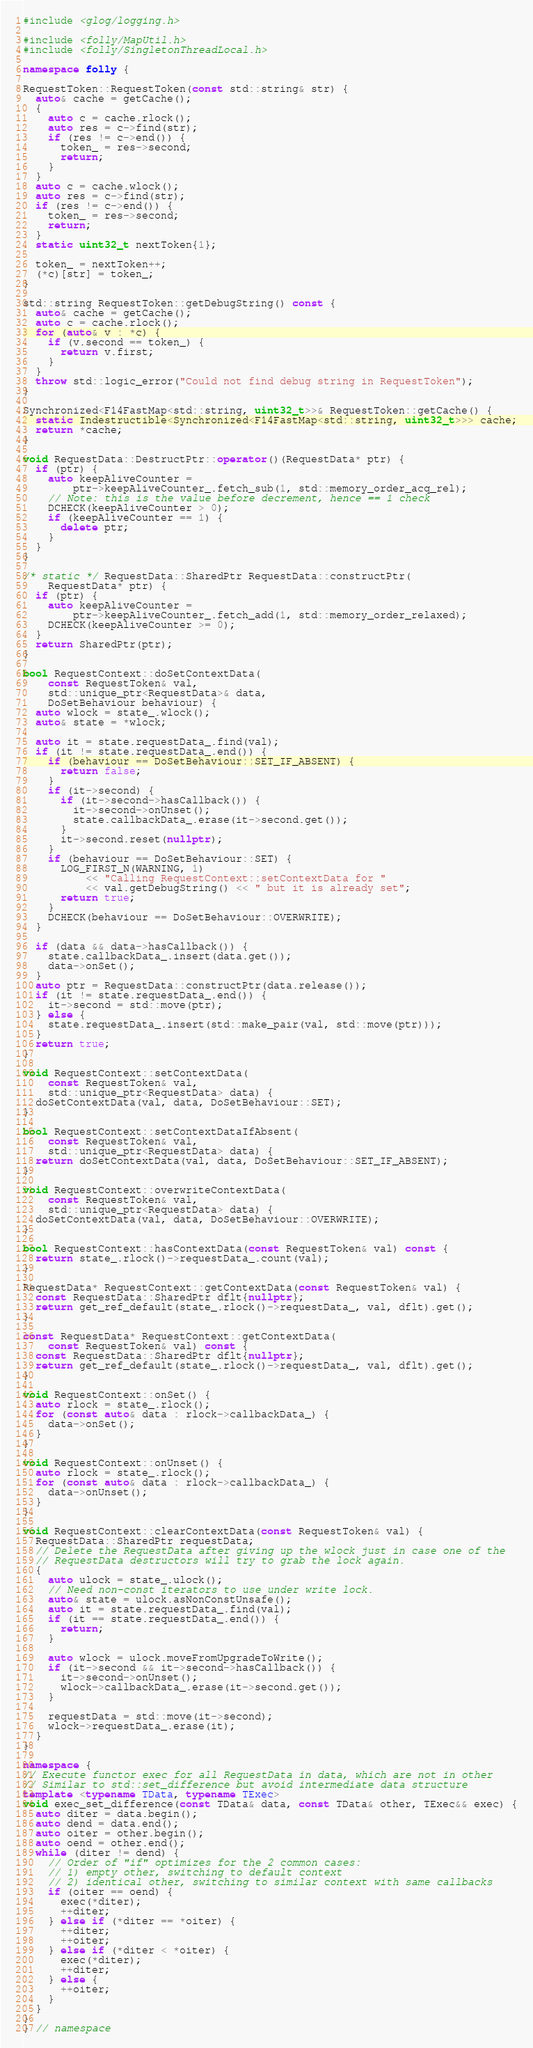<code> <loc_0><loc_0><loc_500><loc_500><_C++_>
#include <glog/logging.h>

#include <folly/MapUtil.h>
#include <folly/SingletonThreadLocal.h>

namespace folly {

RequestToken::RequestToken(const std::string& str) {
  auto& cache = getCache();
  {
    auto c = cache.rlock();
    auto res = c->find(str);
    if (res != c->end()) {
      token_ = res->second;
      return;
    }
  }
  auto c = cache.wlock();
  auto res = c->find(str);
  if (res != c->end()) {
    token_ = res->second;
    return;
  }
  static uint32_t nextToken{1};

  token_ = nextToken++;
  (*c)[str] = token_;
}

std::string RequestToken::getDebugString() const {
  auto& cache = getCache();
  auto c = cache.rlock();
  for (auto& v : *c) {
    if (v.second == token_) {
      return v.first;
    }
  }
  throw std::logic_error("Could not find debug string in RequestToken");
}

Synchronized<F14FastMap<std::string, uint32_t>>& RequestToken::getCache() {
  static Indestructible<Synchronized<F14FastMap<std::string, uint32_t>>> cache;
  return *cache;
}

void RequestData::DestructPtr::operator()(RequestData* ptr) {
  if (ptr) {
    auto keepAliveCounter =
        ptr->keepAliveCounter_.fetch_sub(1, std::memory_order_acq_rel);
    // Note: this is the value before decrement, hence == 1 check
    DCHECK(keepAliveCounter > 0);
    if (keepAliveCounter == 1) {
      delete ptr;
    }
  }
}

/* static */ RequestData::SharedPtr RequestData::constructPtr(
    RequestData* ptr) {
  if (ptr) {
    auto keepAliveCounter =
        ptr->keepAliveCounter_.fetch_add(1, std::memory_order_relaxed);
    DCHECK(keepAliveCounter >= 0);
  }
  return SharedPtr(ptr);
}

bool RequestContext::doSetContextData(
    const RequestToken& val,
    std::unique_ptr<RequestData>& data,
    DoSetBehaviour behaviour) {
  auto wlock = state_.wlock();
  auto& state = *wlock;

  auto it = state.requestData_.find(val);
  if (it != state.requestData_.end()) {
    if (behaviour == DoSetBehaviour::SET_IF_ABSENT) {
      return false;
    }
    if (it->second) {
      if (it->second->hasCallback()) {
        it->second->onUnset();
        state.callbackData_.erase(it->second.get());
      }
      it->second.reset(nullptr);
    }
    if (behaviour == DoSetBehaviour::SET) {
      LOG_FIRST_N(WARNING, 1)
          << "Calling RequestContext::setContextData for "
          << val.getDebugString() << " but it is already set";
      return true;
    }
    DCHECK(behaviour == DoSetBehaviour::OVERWRITE);
  }

  if (data && data->hasCallback()) {
    state.callbackData_.insert(data.get());
    data->onSet();
  }
  auto ptr = RequestData::constructPtr(data.release());
  if (it != state.requestData_.end()) {
    it->second = std::move(ptr);
  } else {
    state.requestData_.insert(std::make_pair(val, std::move(ptr)));
  }
  return true;
}

void RequestContext::setContextData(
    const RequestToken& val,
    std::unique_ptr<RequestData> data) {
  doSetContextData(val, data, DoSetBehaviour::SET);
}

bool RequestContext::setContextDataIfAbsent(
    const RequestToken& val,
    std::unique_ptr<RequestData> data) {
  return doSetContextData(val, data, DoSetBehaviour::SET_IF_ABSENT);
}

void RequestContext::overwriteContextData(
    const RequestToken& val,
    std::unique_ptr<RequestData> data) {
  doSetContextData(val, data, DoSetBehaviour::OVERWRITE);
}

bool RequestContext::hasContextData(const RequestToken& val) const {
  return state_.rlock()->requestData_.count(val);
}

RequestData* RequestContext::getContextData(const RequestToken& val) {
  const RequestData::SharedPtr dflt{nullptr};
  return get_ref_default(state_.rlock()->requestData_, val, dflt).get();
}

const RequestData* RequestContext::getContextData(
    const RequestToken& val) const {
  const RequestData::SharedPtr dflt{nullptr};
  return get_ref_default(state_.rlock()->requestData_, val, dflt).get();
}

void RequestContext::onSet() {
  auto rlock = state_.rlock();
  for (const auto& data : rlock->callbackData_) {
    data->onSet();
  }
}

void RequestContext::onUnset() {
  auto rlock = state_.rlock();
  for (const auto& data : rlock->callbackData_) {
    data->onUnset();
  }
}

void RequestContext::clearContextData(const RequestToken& val) {
  RequestData::SharedPtr requestData;
  // Delete the RequestData after giving up the wlock just in case one of the
  // RequestData destructors will try to grab the lock again.
  {
    auto ulock = state_.ulock();
    // Need non-const iterators to use under write lock.
    auto& state = ulock.asNonConstUnsafe();
    auto it = state.requestData_.find(val);
    if (it == state.requestData_.end()) {
      return;
    }

    auto wlock = ulock.moveFromUpgradeToWrite();
    if (it->second && it->second->hasCallback()) {
      it->second->onUnset();
      wlock->callbackData_.erase(it->second.get());
    }

    requestData = std::move(it->second);
    wlock->requestData_.erase(it);
  }
}

namespace {
// Execute functor exec for all RequestData in data, which are not in other
// Similar to std::set_difference but avoid intermediate data structure
template <typename TData, typename TExec>
void exec_set_difference(const TData& data, const TData& other, TExec&& exec) {
  auto diter = data.begin();
  auto dend = data.end();
  auto oiter = other.begin();
  auto oend = other.end();
  while (diter != dend) {
    // Order of "if" optimizes for the 2 common cases:
    // 1) empty other, switching to default context
    // 2) identical other, switching to similar context with same callbacks
    if (oiter == oend) {
      exec(*diter);
      ++diter;
    } else if (*diter == *oiter) {
      ++diter;
      ++oiter;
    } else if (*diter < *oiter) {
      exec(*diter);
      ++diter;
    } else {
      ++oiter;
    }
  }
}
} // namespace
</code> 